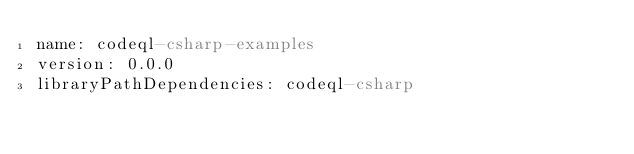<code> <loc_0><loc_0><loc_500><loc_500><_YAML_>name: codeql-csharp-examples
version: 0.0.0
libraryPathDependencies: codeql-csharp
</code> 